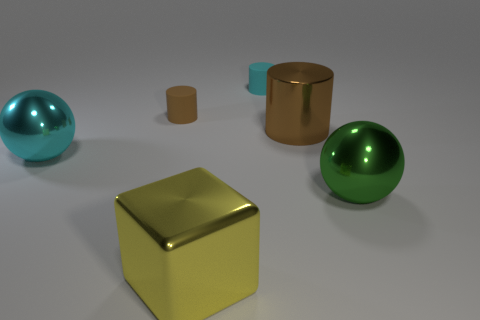What number of objects are either tiny gray matte cubes or cyan balls?
Offer a terse response. 1. What shape is the tiny object that is made of the same material as the cyan cylinder?
Provide a succinct answer. Cylinder. There is a metallic sphere in front of the large metal sphere to the left of the large yellow cube; what size is it?
Ensure brevity in your answer.  Large. What number of small things are either green metallic objects or rubber cylinders?
Give a very brief answer. 2. How many other objects are there of the same color as the block?
Provide a succinct answer. 0. There is a matte cylinder in front of the tiny cyan matte cylinder; does it have the same size as the cyan object that is in front of the brown matte cylinder?
Provide a succinct answer. No. Is the large yellow block made of the same material as the small object that is to the right of the small brown matte cylinder?
Ensure brevity in your answer.  No. Is the number of cyan metal objects to the left of the small brown object greater than the number of big yellow objects that are to the left of the yellow cube?
Keep it short and to the point. Yes. What is the color of the shiny object behind the big metallic ball that is to the left of the green metal ball?
Ensure brevity in your answer.  Brown. What number of blocks are either brown matte things or large cyan rubber things?
Keep it short and to the point. 0. 